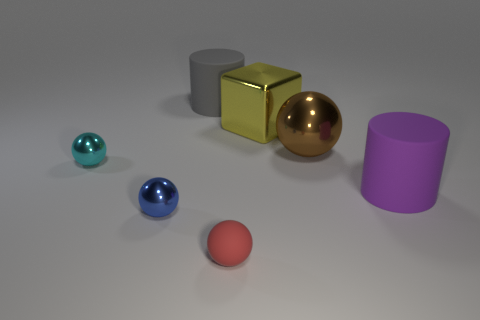Subtract all large metallic balls. How many balls are left? 3 Subtract all purple cylinders. How many cylinders are left? 1 Subtract 1 purple cylinders. How many objects are left? 6 Subtract all blocks. How many objects are left? 6 Subtract 1 cylinders. How many cylinders are left? 1 Subtract all blue blocks. Subtract all cyan spheres. How many blocks are left? 1 Subtract all cyan balls. How many purple cylinders are left? 1 Subtract all red cylinders. Subtract all matte balls. How many objects are left? 6 Add 7 purple matte cylinders. How many purple matte cylinders are left? 8 Add 1 tiny cyan metal spheres. How many tiny cyan metal spheres exist? 2 